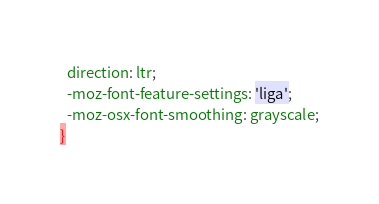<code> <loc_0><loc_0><loc_500><loc_500><_CSS_>  direction: ltr;
  -moz-font-feature-settings: 'liga';
  -moz-osx-font-smoothing: grayscale;
}
</code> 